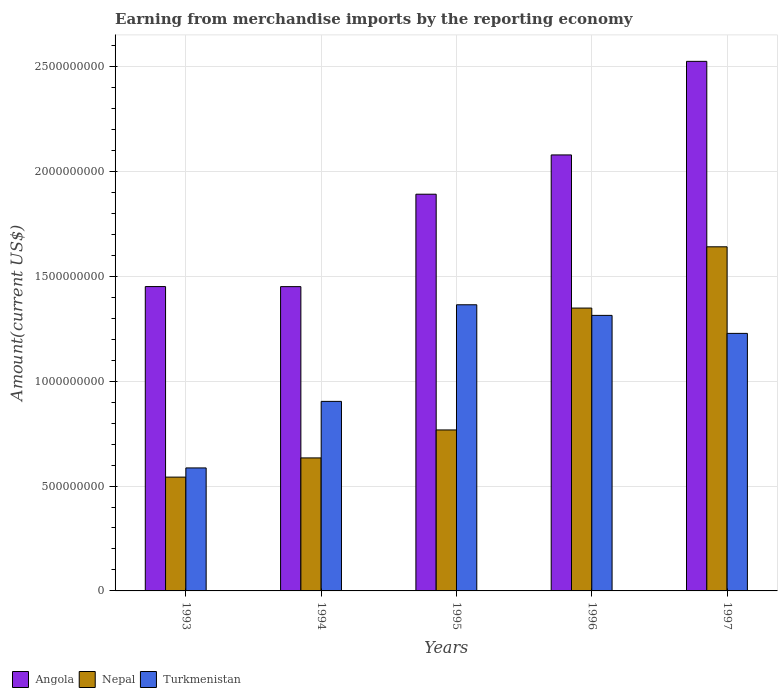Are the number of bars per tick equal to the number of legend labels?
Offer a very short reply. Yes. Are the number of bars on each tick of the X-axis equal?
Your answer should be compact. Yes. How many bars are there on the 4th tick from the right?
Provide a short and direct response. 3. What is the amount earned from merchandise imports in Turkmenistan in 1996?
Offer a very short reply. 1.31e+09. Across all years, what is the maximum amount earned from merchandise imports in Turkmenistan?
Provide a succinct answer. 1.36e+09. Across all years, what is the minimum amount earned from merchandise imports in Angola?
Keep it short and to the point. 1.45e+09. In which year was the amount earned from merchandise imports in Turkmenistan minimum?
Provide a succinct answer. 1993. What is the total amount earned from merchandise imports in Turkmenistan in the graph?
Your answer should be compact. 5.39e+09. What is the difference between the amount earned from merchandise imports in Angola in 1993 and that in 1997?
Offer a very short reply. -1.07e+09. What is the difference between the amount earned from merchandise imports in Turkmenistan in 1993 and the amount earned from merchandise imports in Angola in 1994?
Your answer should be compact. -8.64e+08. What is the average amount earned from merchandise imports in Angola per year?
Your answer should be compact. 1.88e+09. In the year 1993, what is the difference between the amount earned from merchandise imports in Angola and amount earned from merchandise imports in Nepal?
Give a very brief answer. 9.08e+08. In how many years, is the amount earned from merchandise imports in Turkmenistan greater than 2300000000 US$?
Ensure brevity in your answer.  0. What is the ratio of the amount earned from merchandise imports in Turkmenistan in 1994 to that in 1996?
Offer a terse response. 0.69. Is the difference between the amount earned from merchandise imports in Angola in 1994 and 1995 greater than the difference between the amount earned from merchandise imports in Nepal in 1994 and 1995?
Your answer should be very brief. No. What is the difference between the highest and the second highest amount earned from merchandise imports in Turkmenistan?
Keep it short and to the point. 5.06e+07. What is the difference between the highest and the lowest amount earned from merchandise imports in Angola?
Keep it short and to the point. 1.07e+09. In how many years, is the amount earned from merchandise imports in Turkmenistan greater than the average amount earned from merchandise imports in Turkmenistan taken over all years?
Your response must be concise. 3. Is the sum of the amount earned from merchandise imports in Angola in 1994 and 1996 greater than the maximum amount earned from merchandise imports in Turkmenistan across all years?
Provide a short and direct response. Yes. What does the 1st bar from the left in 1994 represents?
Provide a short and direct response. Angola. What does the 3rd bar from the right in 1996 represents?
Your response must be concise. Angola. Is it the case that in every year, the sum of the amount earned from merchandise imports in Angola and amount earned from merchandise imports in Turkmenistan is greater than the amount earned from merchandise imports in Nepal?
Your response must be concise. Yes. How many bars are there?
Provide a short and direct response. 15. What is the difference between two consecutive major ticks on the Y-axis?
Your response must be concise. 5.00e+08. Does the graph contain grids?
Ensure brevity in your answer.  Yes. Where does the legend appear in the graph?
Offer a terse response. Bottom left. How many legend labels are there?
Offer a very short reply. 3. How are the legend labels stacked?
Provide a succinct answer. Horizontal. What is the title of the graph?
Your response must be concise. Earning from merchandise imports by the reporting economy. What is the label or title of the X-axis?
Offer a very short reply. Years. What is the label or title of the Y-axis?
Your answer should be compact. Amount(current US$). What is the Amount(current US$) of Angola in 1993?
Ensure brevity in your answer.  1.45e+09. What is the Amount(current US$) of Nepal in 1993?
Provide a succinct answer. 5.42e+08. What is the Amount(current US$) in Turkmenistan in 1993?
Provide a succinct answer. 5.86e+08. What is the Amount(current US$) of Angola in 1994?
Ensure brevity in your answer.  1.45e+09. What is the Amount(current US$) in Nepal in 1994?
Ensure brevity in your answer.  6.34e+08. What is the Amount(current US$) of Turkmenistan in 1994?
Your answer should be very brief. 9.04e+08. What is the Amount(current US$) of Angola in 1995?
Your answer should be compact. 1.89e+09. What is the Amount(current US$) of Nepal in 1995?
Give a very brief answer. 7.67e+08. What is the Amount(current US$) of Turkmenistan in 1995?
Make the answer very short. 1.36e+09. What is the Amount(current US$) in Angola in 1996?
Keep it short and to the point. 2.08e+09. What is the Amount(current US$) in Nepal in 1996?
Your answer should be compact. 1.35e+09. What is the Amount(current US$) of Turkmenistan in 1996?
Ensure brevity in your answer.  1.31e+09. What is the Amount(current US$) in Angola in 1997?
Give a very brief answer. 2.52e+09. What is the Amount(current US$) of Nepal in 1997?
Give a very brief answer. 1.64e+09. What is the Amount(current US$) in Turkmenistan in 1997?
Ensure brevity in your answer.  1.23e+09. Across all years, what is the maximum Amount(current US$) in Angola?
Offer a terse response. 2.52e+09. Across all years, what is the maximum Amount(current US$) in Nepal?
Provide a short and direct response. 1.64e+09. Across all years, what is the maximum Amount(current US$) of Turkmenistan?
Offer a very short reply. 1.36e+09. Across all years, what is the minimum Amount(current US$) in Angola?
Offer a terse response. 1.45e+09. Across all years, what is the minimum Amount(current US$) of Nepal?
Provide a short and direct response. 5.42e+08. Across all years, what is the minimum Amount(current US$) in Turkmenistan?
Your answer should be very brief. 5.86e+08. What is the total Amount(current US$) in Angola in the graph?
Your response must be concise. 9.40e+09. What is the total Amount(current US$) of Nepal in the graph?
Provide a short and direct response. 4.93e+09. What is the total Amount(current US$) of Turkmenistan in the graph?
Offer a terse response. 5.39e+09. What is the difference between the Amount(current US$) of Angola in 1993 and that in 1994?
Provide a short and direct response. 2.85e+05. What is the difference between the Amount(current US$) of Nepal in 1993 and that in 1994?
Keep it short and to the point. -9.16e+07. What is the difference between the Amount(current US$) in Turkmenistan in 1993 and that in 1994?
Your response must be concise. -3.17e+08. What is the difference between the Amount(current US$) in Angola in 1993 and that in 1995?
Offer a very short reply. -4.40e+08. What is the difference between the Amount(current US$) in Nepal in 1993 and that in 1995?
Make the answer very short. -2.25e+08. What is the difference between the Amount(current US$) in Turkmenistan in 1993 and that in 1995?
Keep it short and to the point. -7.78e+08. What is the difference between the Amount(current US$) in Angola in 1993 and that in 1996?
Your answer should be very brief. -6.28e+08. What is the difference between the Amount(current US$) in Nepal in 1993 and that in 1996?
Your answer should be compact. -8.06e+08. What is the difference between the Amount(current US$) of Turkmenistan in 1993 and that in 1996?
Ensure brevity in your answer.  -7.27e+08. What is the difference between the Amount(current US$) of Angola in 1993 and that in 1997?
Your answer should be very brief. -1.07e+09. What is the difference between the Amount(current US$) of Nepal in 1993 and that in 1997?
Keep it short and to the point. -1.10e+09. What is the difference between the Amount(current US$) of Turkmenistan in 1993 and that in 1997?
Make the answer very short. -6.41e+08. What is the difference between the Amount(current US$) of Angola in 1994 and that in 1995?
Keep it short and to the point. -4.41e+08. What is the difference between the Amount(current US$) of Nepal in 1994 and that in 1995?
Offer a terse response. -1.33e+08. What is the difference between the Amount(current US$) of Turkmenistan in 1994 and that in 1995?
Your answer should be compact. -4.60e+08. What is the difference between the Amount(current US$) of Angola in 1994 and that in 1996?
Provide a succinct answer. -6.28e+08. What is the difference between the Amount(current US$) in Nepal in 1994 and that in 1996?
Offer a terse response. -7.14e+08. What is the difference between the Amount(current US$) of Turkmenistan in 1994 and that in 1996?
Your response must be concise. -4.10e+08. What is the difference between the Amount(current US$) in Angola in 1994 and that in 1997?
Keep it short and to the point. -1.07e+09. What is the difference between the Amount(current US$) in Nepal in 1994 and that in 1997?
Offer a terse response. -1.01e+09. What is the difference between the Amount(current US$) of Turkmenistan in 1994 and that in 1997?
Offer a very short reply. -3.24e+08. What is the difference between the Amount(current US$) of Angola in 1995 and that in 1996?
Your answer should be very brief. -1.87e+08. What is the difference between the Amount(current US$) in Nepal in 1995 and that in 1996?
Make the answer very short. -5.81e+08. What is the difference between the Amount(current US$) of Turkmenistan in 1995 and that in 1996?
Keep it short and to the point. 5.06e+07. What is the difference between the Amount(current US$) of Angola in 1995 and that in 1997?
Ensure brevity in your answer.  -6.33e+08. What is the difference between the Amount(current US$) of Nepal in 1995 and that in 1997?
Ensure brevity in your answer.  -8.73e+08. What is the difference between the Amount(current US$) of Turkmenistan in 1995 and that in 1997?
Ensure brevity in your answer.  1.36e+08. What is the difference between the Amount(current US$) of Angola in 1996 and that in 1997?
Offer a terse response. -4.46e+08. What is the difference between the Amount(current US$) in Nepal in 1996 and that in 1997?
Your answer should be compact. -2.92e+08. What is the difference between the Amount(current US$) of Turkmenistan in 1996 and that in 1997?
Offer a very short reply. 8.58e+07. What is the difference between the Amount(current US$) in Angola in 1993 and the Amount(current US$) in Nepal in 1994?
Your answer should be very brief. 8.17e+08. What is the difference between the Amount(current US$) of Angola in 1993 and the Amount(current US$) of Turkmenistan in 1994?
Give a very brief answer. 5.47e+08. What is the difference between the Amount(current US$) in Nepal in 1993 and the Amount(current US$) in Turkmenistan in 1994?
Your answer should be very brief. -3.61e+08. What is the difference between the Amount(current US$) of Angola in 1993 and the Amount(current US$) of Nepal in 1995?
Your answer should be very brief. 6.83e+08. What is the difference between the Amount(current US$) of Angola in 1993 and the Amount(current US$) of Turkmenistan in 1995?
Your answer should be compact. 8.68e+07. What is the difference between the Amount(current US$) in Nepal in 1993 and the Amount(current US$) in Turkmenistan in 1995?
Keep it short and to the point. -8.22e+08. What is the difference between the Amount(current US$) of Angola in 1993 and the Amount(current US$) of Nepal in 1996?
Your answer should be very brief. 1.03e+08. What is the difference between the Amount(current US$) in Angola in 1993 and the Amount(current US$) in Turkmenistan in 1996?
Your response must be concise. 1.37e+08. What is the difference between the Amount(current US$) in Nepal in 1993 and the Amount(current US$) in Turkmenistan in 1996?
Your answer should be compact. -7.71e+08. What is the difference between the Amount(current US$) of Angola in 1993 and the Amount(current US$) of Nepal in 1997?
Your answer should be very brief. -1.90e+08. What is the difference between the Amount(current US$) in Angola in 1993 and the Amount(current US$) in Turkmenistan in 1997?
Make the answer very short. 2.23e+08. What is the difference between the Amount(current US$) in Nepal in 1993 and the Amount(current US$) in Turkmenistan in 1997?
Your answer should be very brief. -6.85e+08. What is the difference between the Amount(current US$) of Angola in 1994 and the Amount(current US$) of Nepal in 1995?
Provide a succinct answer. 6.83e+08. What is the difference between the Amount(current US$) of Angola in 1994 and the Amount(current US$) of Turkmenistan in 1995?
Provide a short and direct response. 8.65e+07. What is the difference between the Amount(current US$) of Nepal in 1994 and the Amount(current US$) of Turkmenistan in 1995?
Your answer should be very brief. -7.30e+08. What is the difference between the Amount(current US$) of Angola in 1994 and the Amount(current US$) of Nepal in 1996?
Your answer should be very brief. 1.02e+08. What is the difference between the Amount(current US$) in Angola in 1994 and the Amount(current US$) in Turkmenistan in 1996?
Ensure brevity in your answer.  1.37e+08. What is the difference between the Amount(current US$) of Nepal in 1994 and the Amount(current US$) of Turkmenistan in 1996?
Offer a very short reply. -6.79e+08. What is the difference between the Amount(current US$) in Angola in 1994 and the Amount(current US$) in Nepal in 1997?
Provide a short and direct response. -1.90e+08. What is the difference between the Amount(current US$) in Angola in 1994 and the Amount(current US$) in Turkmenistan in 1997?
Your response must be concise. 2.23e+08. What is the difference between the Amount(current US$) in Nepal in 1994 and the Amount(current US$) in Turkmenistan in 1997?
Provide a succinct answer. -5.94e+08. What is the difference between the Amount(current US$) in Angola in 1995 and the Amount(current US$) in Nepal in 1996?
Provide a short and direct response. 5.43e+08. What is the difference between the Amount(current US$) in Angola in 1995 and the Amount(current US$) in Turkmenistan in 1996?
Your answer should be very brief. 5.78e+08. What is the difference between the Amount(current US$) in Nepal in 1995 and the Amount(current US$) in Turkmenistan in 1996?
Offer a very short reply. -5.46e+08. What is the difference between the Amount(current US$) in Angola in 1995 and the Amount(current US$) in Nepal in 1997?
Your answer should be compact. 2.51e+08. What is the difference between the Amount(current US$) of Angola in 1995 and the Amount(current US$) of Turkmenistan in 1997?
Provide a short and direct response. 6.63e+08. What is the difference between the Amount(current US$) in Nepal in 1995 and the Amount(current US$) in Turkmenistan in 1997?
Give a very brief answer. -4.60e+08. What is the difference between the Amount(current US$) in Angola in 1996 and the Amount(current US$) in Nepal in 1997?
Provide a short and direct response. 4.38e+08. What is the difference between the Amount(current US$) in Angola in 1996 and the Amount(current US$) in Turkmenistan in 1997?
Keep it short and to the point. 8.51e+08. What is the difference between the Amount(current US$) in Nepal in 1996 and the Amount(current US$) in Turkmenistan in 1997?
Provide a succinct answer. 1.21e+08. What is the average Amount(current US$) of Angola per year?
Your response must be concise. 1.88e+09. What is the average Amount(current US$) of Nepal per year?
Offer a terse response. 9.87e+08. What is the average Amount(current US$) of Turkmenistan per year?
Provide a short and direct response. 1.08e+09. In the year 1993, what is the difference between the Amount(current US$) in Angola and Amount(current US$) in Nepal?
Offer a terse response. 9.08e+08. In the year 1993, what is the difference between the Amount(current US$) in Angola and Amount(current US$) in Turkmenistan?
Give a very brief answer. 8.65e+08. In the year 1993, what is the difference between the Amount(current US$) in Nepal and Amount(current US$) in Turkmenistan?
Give a very brief answer. -4.39e+07. In the year 1994, what is the difference between the Amount(current US$) of Angola and Amount(current US$) of Nepal?
Give a very brief answer. 8.16e+08. In the year 1994, what is the difference between the Amount(current US$) of Angola and Amount(current US$) of Turkmenistan?
Your answer should be compact. 5.47e+08. In the year 1994, what is the difference between the Amount(current US$) in Nepal and Amount(current US$) in Turkmenistan?
Make the answer very short. -2.69e+08. In the year 1995, what is the difference between the Amount(current US$) in Angola and Amount(current US$) in Nepal?
Keep it short and to the point. 1.12e+09. In the year 1995, what is the difference between the Amount(current US$) in Angola and Amount(current US$) in Turkmenistan?
Your answer should be compact. 5.27e+08. In the year 1995, what is the difference between the Amount(current US$) of Nepal and Amount(current US$) of Turkmenistan?
Your response must be concise. -5.97e+08. In the year 1996, what is the difference between the Amount(current US$) of Angola and Amount(current US$) of Nepal?
Make the answer very short. 7.30e+08. In the year 1996, what is the difference between the Amount(current US$) in Angola and Amount(current US$) in Turkmenistan?
Your response must be concise. 7.65e+08. In the year 1996, what is the difference between the Amount(current US$) in Nepal and Amount(current US$) in Turkmenistan?
Your answer should be very brief. 3.48e+07. In the year 1997, what is the difference between the Amount(current US$) in Angola and Amount(current US$) in Nepal?
Give a very brief answer. 8.84e+08. In the year 1997, what is the difference between the Amount(current US$) in Angola and Amount(current US$) in Turkmenistan?
Your answer should be compact. 1.30e+09. In the year 1997, what is the difference between the Amount(current US$) of Nepal and Amount(current US$) of Turkmenistan?
Your response must be concise. 4.13e+08. What is the ratio of the Amount(current US$) in Nepal in 1993 to that in 1994?
Your answer should be very brief. 0.86. What is the ratio of the Amount(current US$) in Turkmenistan in 1993 to that in 1994?
Keep it short and to the point. 0.65. What is the ratio of the Amount(current US$) in Angola in 1993 to that in 1995?
Offer a terse response. 0.77. What is the ratio of the Amount(current US$) in Nepal in 1993 to that in 1995?
Offer a terse response. 0.71. What is the ratio of the Amount(current US$) of Turkmenistan in 1993 to that in 1995?
Provide a succinct answer. 0.43. What is the ratio of the Amount(current US$) in Angola in 1993 to that in 1996?
Your answer should be very brief. 0.7. What is the ratio of the Amount(current US$) of Nepal in 1993 to that in 1996?
Provide a short and direct response. 0.4. What is the ratio of the Amount(current US$) in Turkmenistan in 1993 to that in 1996?
Provide a short and direct response. 0.45. What is the ratio of the Amount(current US$) in Angola in 1993 to that in 1997?
Provide a succinct answer. 0.57. What is the ratio of the Amount(current US$) of Nepal in 1993 to that in 1997?
Ensure brevity in your answer.  0.33. What is the ratio of the Amount(current US$) of Turkmenistan in 1993 to that in 1997?
Your answer should be very brief. 0.48. What is the ratio of the Amount(current US$) in Angola in 1994 to that in 1995?
Make the answer very short. 0.77. What is the ratio of the Amount(current US$) of Nepal in 1994 to that in 1995?
Your response must be concise. 0.83. What is the ratio of the Amount(current US$) of Turkmenistan in 1994 to that in 1995?
Offer a very short reply. 0.66. What is the ratio of the Amount(current US$) of Angola in 1994 to that in 1996?
Give a very brief answer. 0.7. What is the ratio of the Amount(current US$) of Nepal in 1994 to that in 1996?
Your response must be concise. 0.47. What is the ratio of the Amount(current US$) in Turkmenistan in 1994 to that in 1996?
Keep it short and to the point. 0.69. What is the ratio of the Amount(current US$) in Angola in 1994 to that in 1997?
Ensure brevity in your answer.  0.57. What is the ratio of the Amount(current US$) of Nepal in 1994 to that in 1997?
Provide a succinct answer. 0.39. What is the ratio of the Amount(current US$) in Turkmenistan in 1994 to that in 1997?
Your answer should be compact. 0.74. What is the ratio of the Amount(current US$) of Angola in 1995 to that in 1996?
Your response must be concise. 0.91. What is the ratio of the Amount(current US$) of Nepal in 1995 to that in 1996?
Your answer should be very brief. 0.57. What is the ratio of the Amount(current US$) in Turkmenistan in 1995 to that in 1996?
Give a very brief answer. 1.04. What is the ratio of the Amount(current US$) in Angola in 1995 to that in 1997?
Your answer should be compact. 0.75. What is the ratio of the Amount(current US$) of Nepal in 1995 to that in 1997?
Provide a succinct answer. 0.47. What is the ratio of the Amount(current US$) of Turkmenistan in 1995 to that in 1997?
Provide a succinct answer. 1.11. What is the ratio of the Amount(current US$) in Angola in 1996 to that in 1997?
Ensure brevity in your answer.  0.82. What is the ratio of the Amount(current US$) of Nepal in 1996 to that in 1997?
Your response must be concise. 0.82. What is the ratio of the Amount(current US$) of Turkmenistan in 1996 to that in 1997?
Offer a very short reply. 1.07. What is the difference between the highest and the second highest Amount(current US$) of Angola?
Your answer should be very brief. 4.46e+08. What is the difference between the highest and the second highest Amount(current US$) in Nepal?
Keep it short and to the point. 2.92e+08. What is the difference between the highest and the second highest Amount(current US$) in Turkmenistan?
Offer a very short reply. 5.06e+07. What is the difference between the highest and the lowest Amount(current US$) of Angola?
Provide a short and direct response. 1.07e+09. What is the difference between the highest and the lowest Amount(current US$) of Nepal?
Ensure brevity in your answer.  1.10e+09. What is the difference between the highest and the lowest Amount(current US$) in Turkmenistan?
Keep it short and to the point. 7.78e+08. 